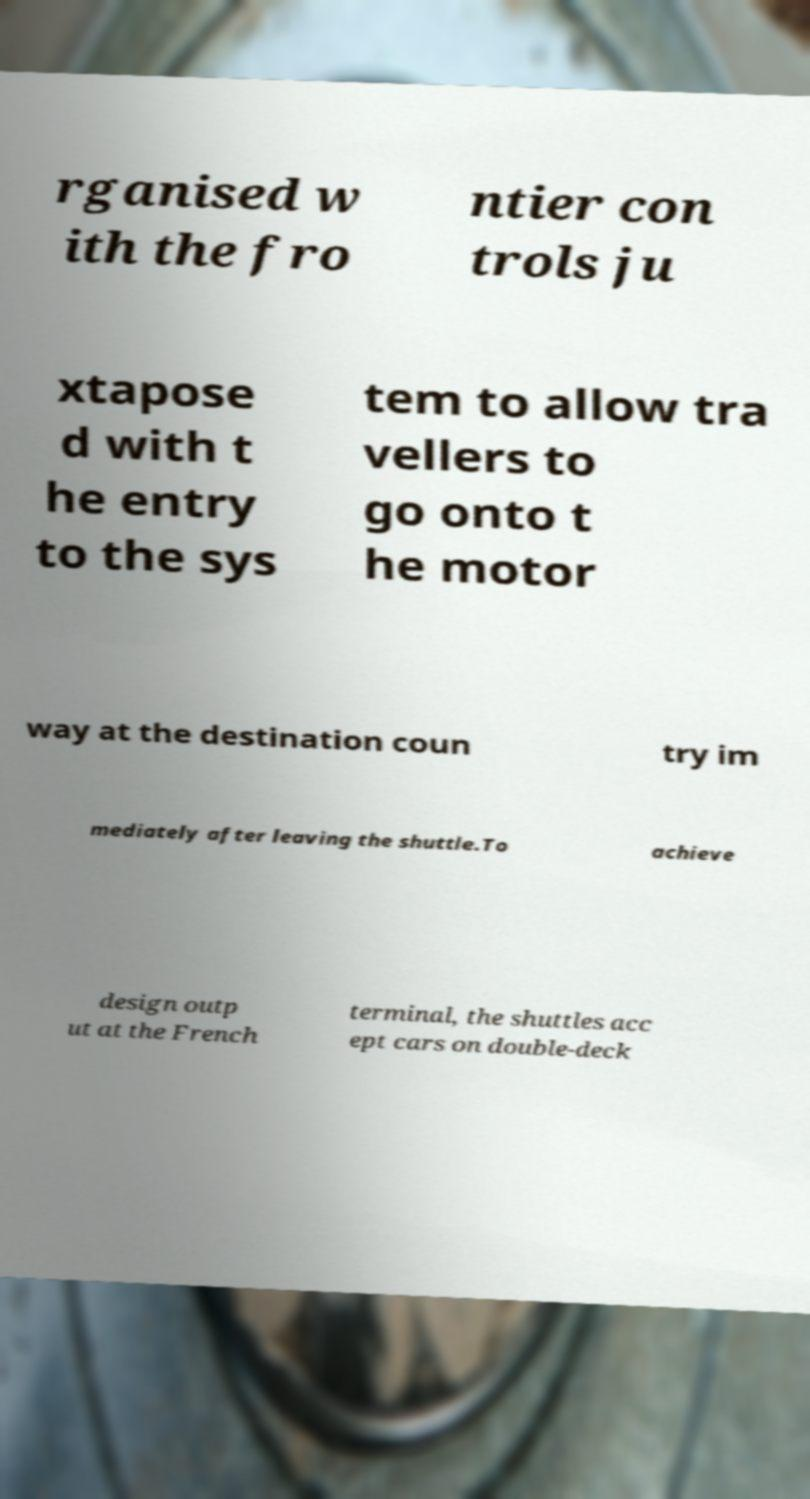Please identify and transcribe the text found in this image. rganised w ith the fro ntier con trols ju xtapose d with t he entry to the sys tem to allow tra vellers to go onto t he motor way at the destination coun try im mediately after leaving the shuttle.To achieve design outp ut at the French terminal, the shuttles acc ept cars on double-deck 